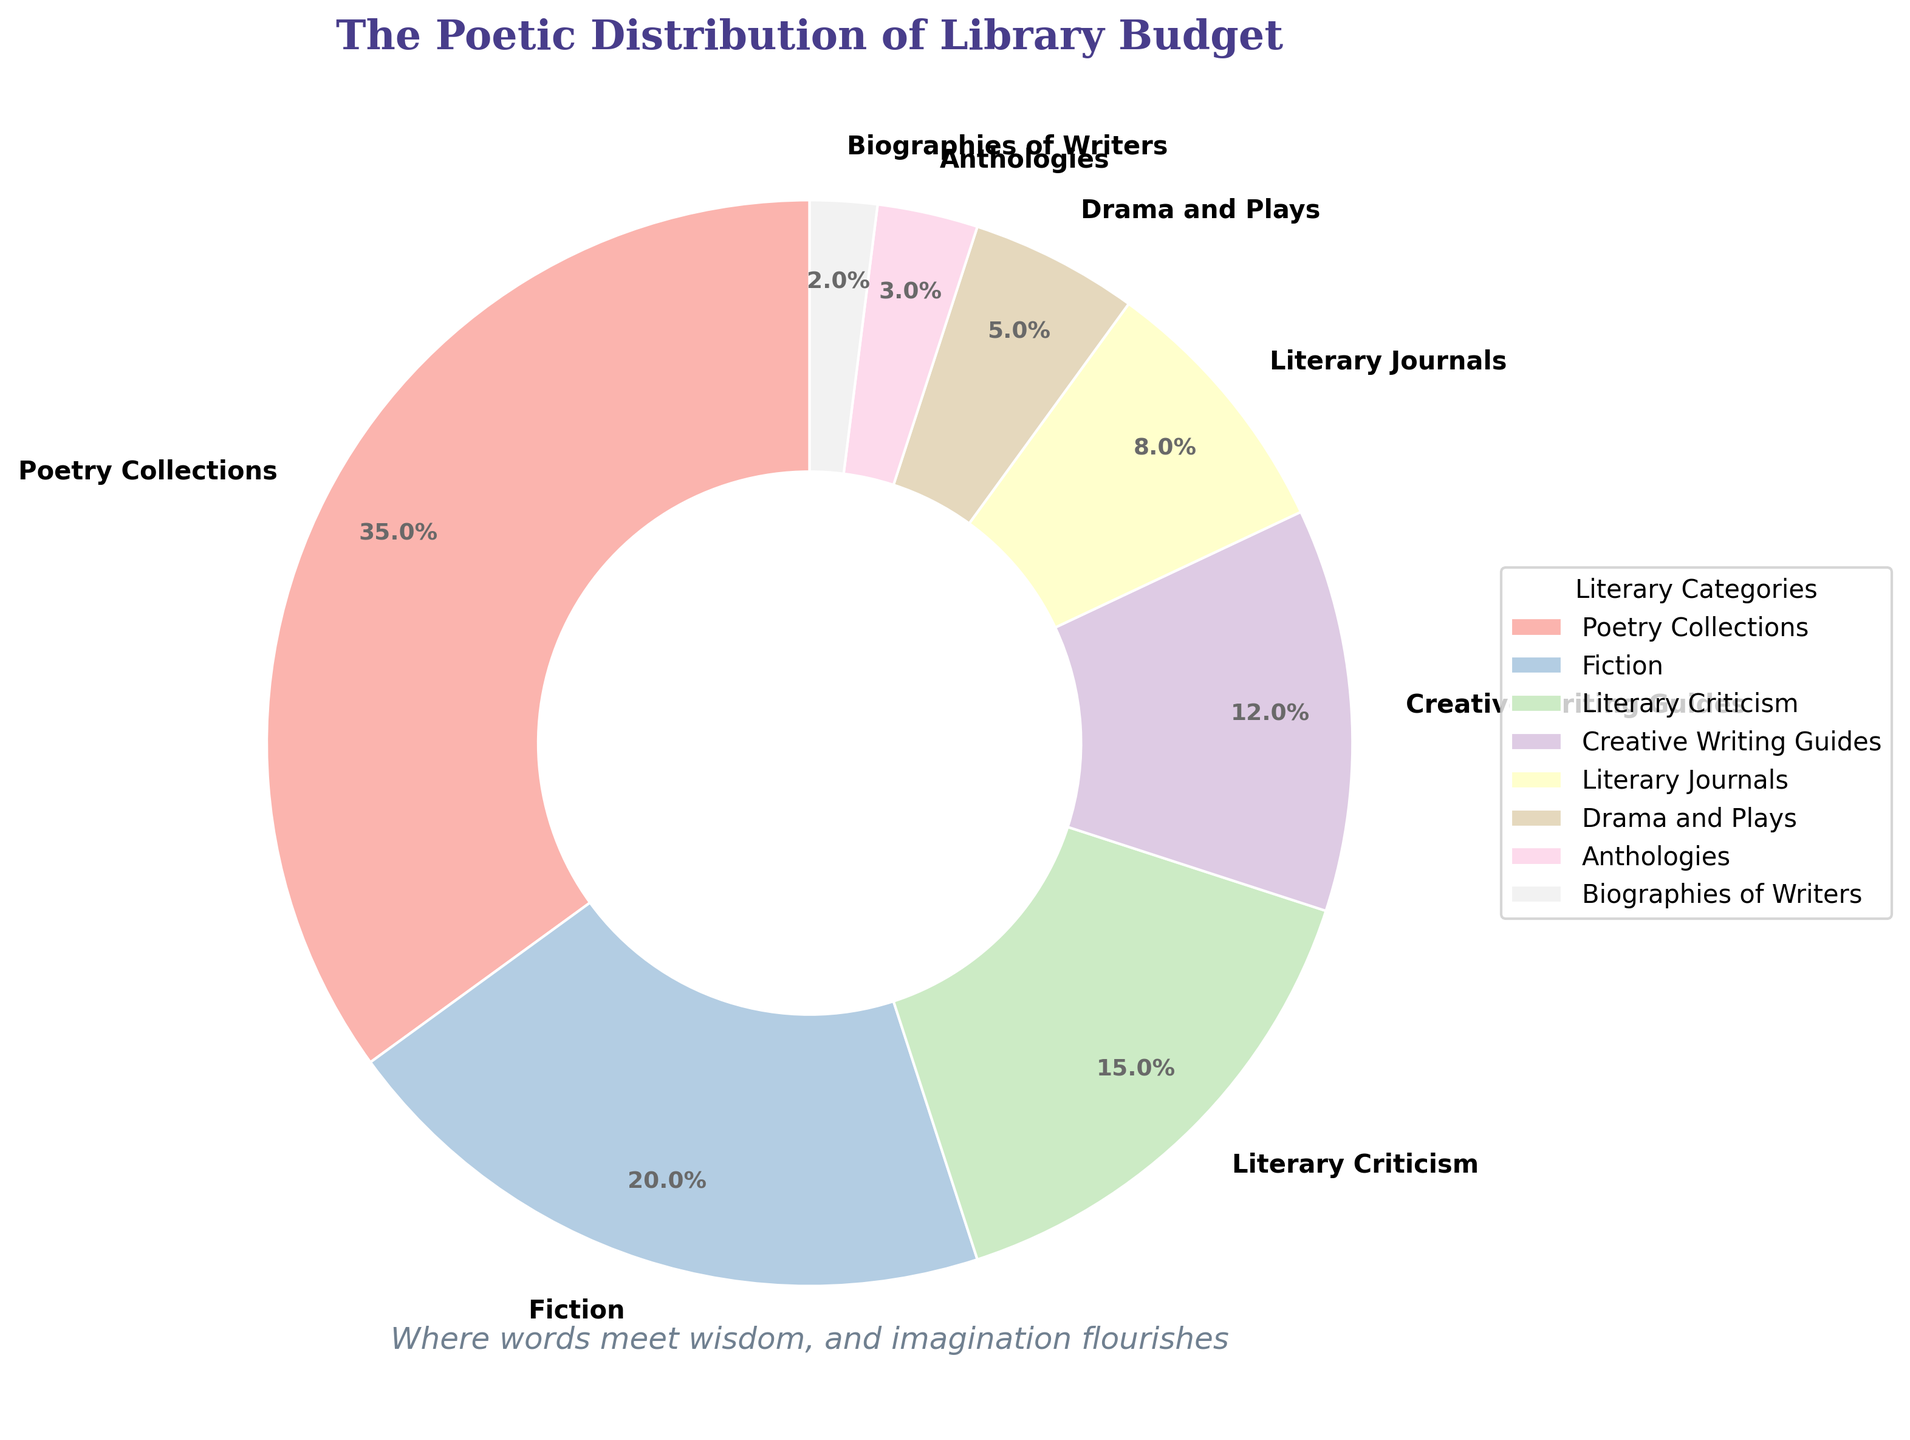What's the category with the largest portion of the library budget allocation? The pie chart shows that "Poetry Collections" has the largest portion, represented by the biggest wedge with a percentage label of 35%.
Answer: Poetry Collections Which category has the smallest budget allocation? According to the pie chart, "Biographies of Writers" has the smallest wedge, indicating it has the lowest budget allocation with a percentage of 2%.
Answer: Biographies of Writers What is the total budget allocation for Fiction and Literary Criticism combined? Adding the percentages for "Fiction" (20%) and "Literary Criticism" (15%) gives a total budget allocation of 35%.
Answer: 35% How does the budget allocated to Creative Writing Guides compare to that for Literary Journals? The budget for "Creative Writing Guides" is 12%, whereas "Literary Journals" have 8%. Creative Writing Guides have a larger budget allocation.
Answer: Creative Writing Guides What is the total budget allocation for the categories that receive less than 10% each? Adding the percentages for "Literary Journals" (8%), "Drama and Plays" (5%), "Anthologies" (3%), and "Biographies of Writers" (2%) gives a total of 18%.
Answer: 18% How much more budget is allocated to Poetry Collections compared to Drama and Plays? The budget for "Poetry Collections" is 35%, and for "Drama and Plays" it is 5%. Subtracting 5% from 35% gives a difference of 30%.
Answer: 30% If an additional 5% budget was equally divided between Fiction and Creative Writing Guides, what would their new allocations be? Since fiction currently has 20% and Creative Writing Guides have 12%, adding 2.5% to each (half of 5%) would give fiction 22.5% and Creative Writing Guides 14.5%.
Answer: Fiction: 22.5%, Creative Writing Guides: 14.5% What is the difference in budget allocation between the category with the highest percentage and the one with the second-highest percentage? The highest is "Poetry Collections" at 35%, and the second-highest is "Fiction" at 20%. The difference is 35% - 20% = 15%.
Answer: 15% Which categories have a budget allocation higher than the average allocation for all categories? First, calculate the average: (35 + 20 + 15 + 12 + 8 + 5 + 3 + 2) / 8 = 100 / 8 = 12.5%. Categories above this average are "Poetry Collections" (35%), "Fiction" (20%), and "Literary Criticism" (15%).
Answer: Poetry Collections, Fiction, Literary Criticism 